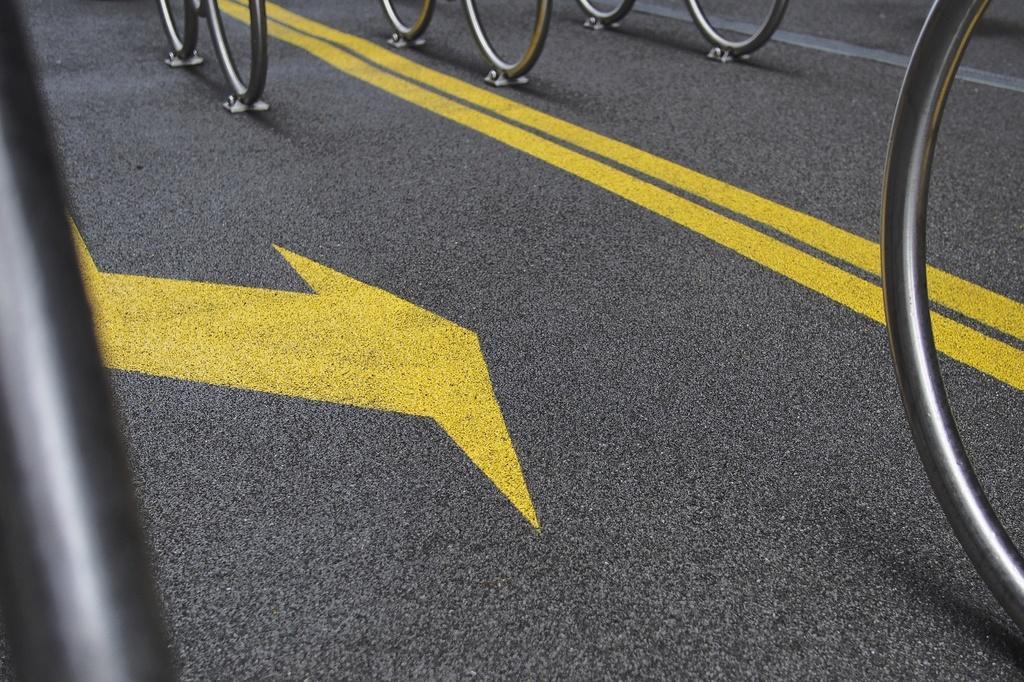Can you describe this image briefly? In this image there is a road on which there are metal rings which are kept on the road. On the road there is a direction. 